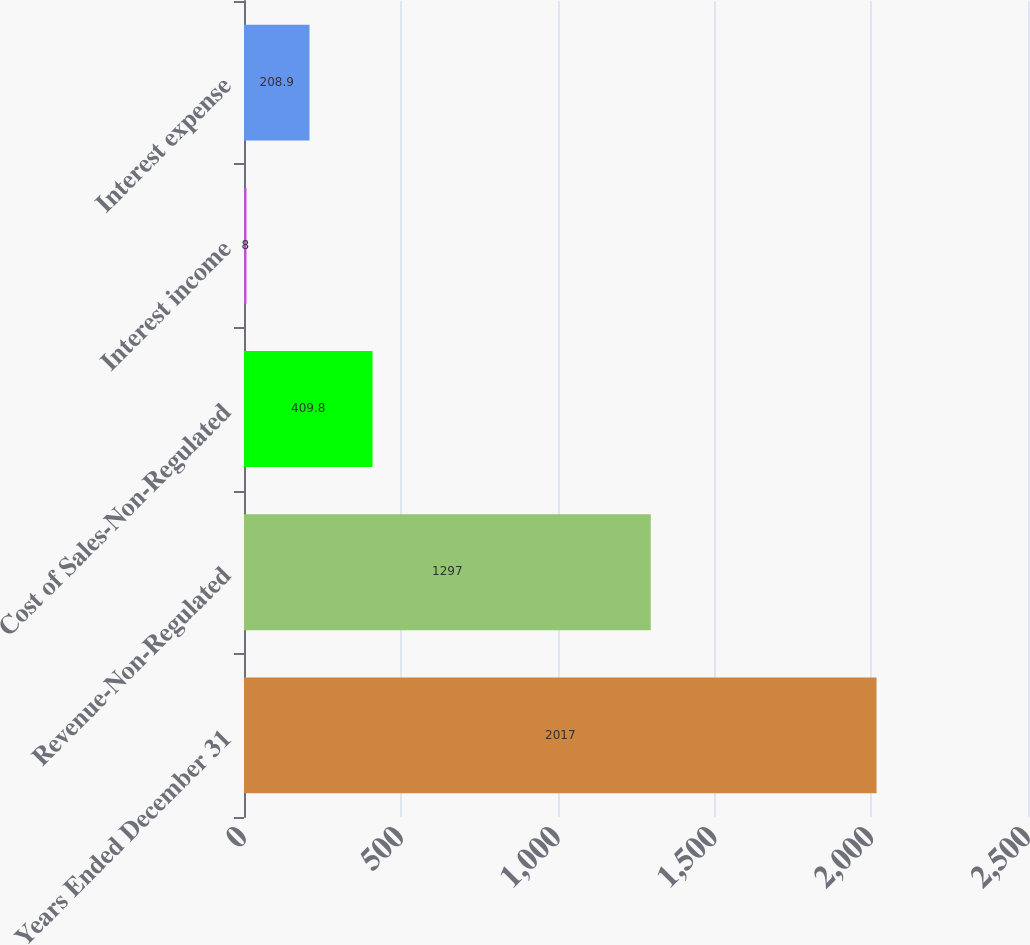<chart> <loc_0><loc_0><loc_500><loc_500><bar_chart><fcel>Years Ended December 31<fcel>Revenue-Non-Regulated<fcel>Cost of Sales-Non-Regulated<fcel>Interest income<fcel>Interest expense<nl><fcel>2017<fcel>1297<fcel>409.8<fcel>8<fcel>208.9<nl></chart> 